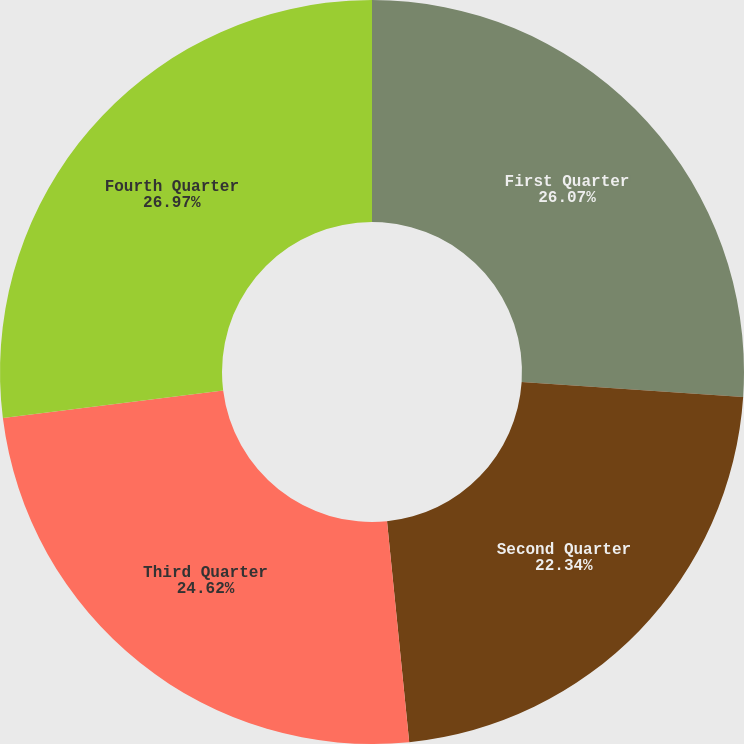Convert chart. <chart><loc_0><loc_0><loc_500><loc_500><pie_chart><fcel>First Quarter<fcel>Second Quarter<fcel>Third Quarter<fcel>Fourth Quarter<nl><fcel>26.07%<fcel>22.34%<fcel>24.62%<fcel>26.98%<nl></chart> 